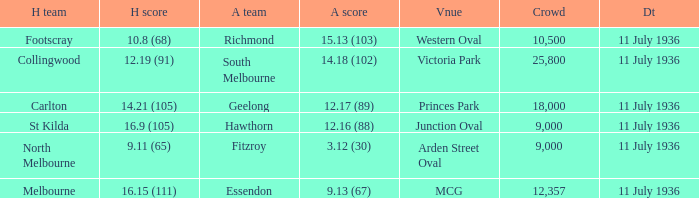Help me parse the entirety of this table. {'header': ['H team', 'H score', 'A team', 'A score', 'Vnue', 'Crowd', 'Dt'], 'rows': [['Footscray', '10.8 (68)', 'Richmond', '15.13 (103)', 'Western Oval', '10,500', '11 July 1936'], ['Collingwood', '12.19 (91)', 'South Melbourne', '14.18 (102)', 'Victoria Park', '25,800', '11 July 1936'], ['Carlton', '14.21 (105)', 'Geelong', '12.17 (89)', 'Princes Park', '18,000', '11 July 1936'], ['St Kilda', '16.9 (105)', 'Hawthorn', '12.16 (88)', 'Junction Oval', '9,000', '11 July 1936'], ['North Melbourne', '9.11 (65)', 'Fitzroy', '3.12 (30)', 'Arden Street Oval', '9,000', '11 July 1936'], ['Melbourne', '16.15 (111)', 'Essendon', '9.13 (67)', 'MCG', '12,357', '11 July 1936']]} What is the lowest crowd seen by the mcg Venue? 12357.0. 